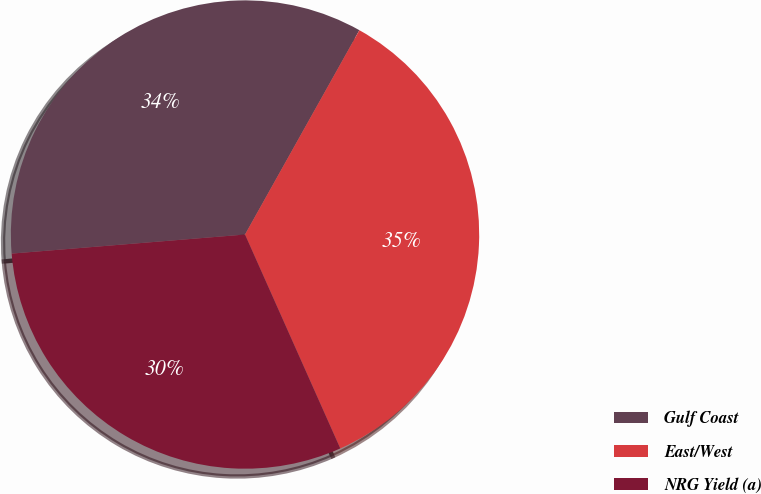<chart> <loc_0><loc_0><loc_500><loc_500><pie_chart><fcel>Gulf Coast<fcel>East/West<fcel>NRG Yield (a)<nl><fcel>34.42%<fcel>35.21%<fcel>30.37%<nl></chart> 